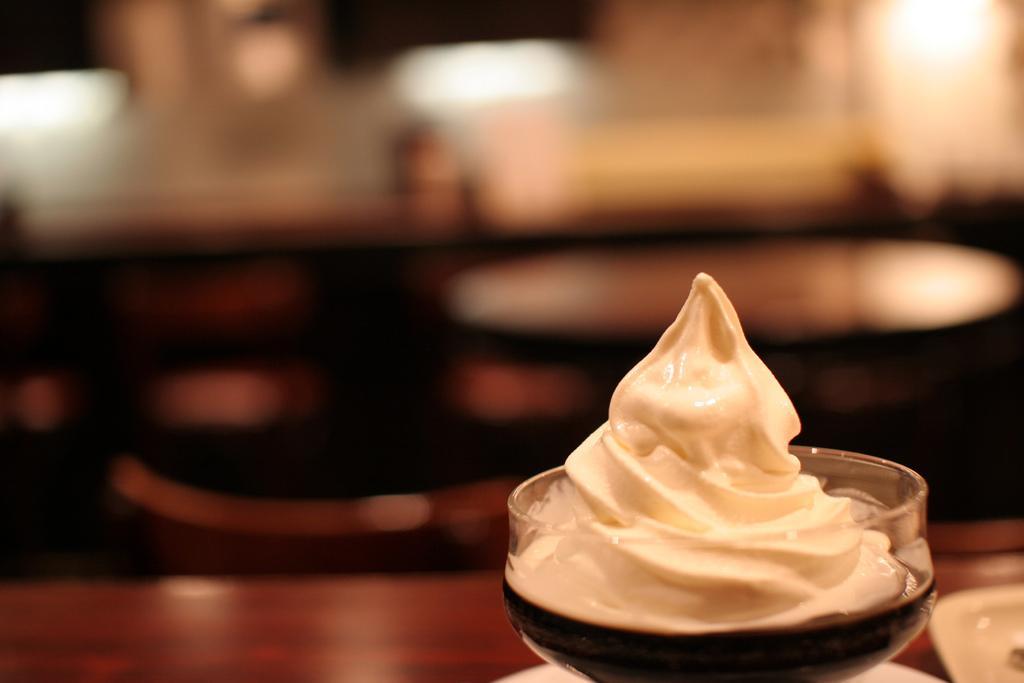In one or two sentences, can you explain what this image depicts? In this image, we can see an ice cream in the glass and there are some other objects, which are placed on the table and the background is blurry. 